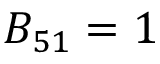Convert formula to latex. <formula><loc_0><loc_0><loc_500><loc_500>B _ { 5 1 } = 1</formula> 